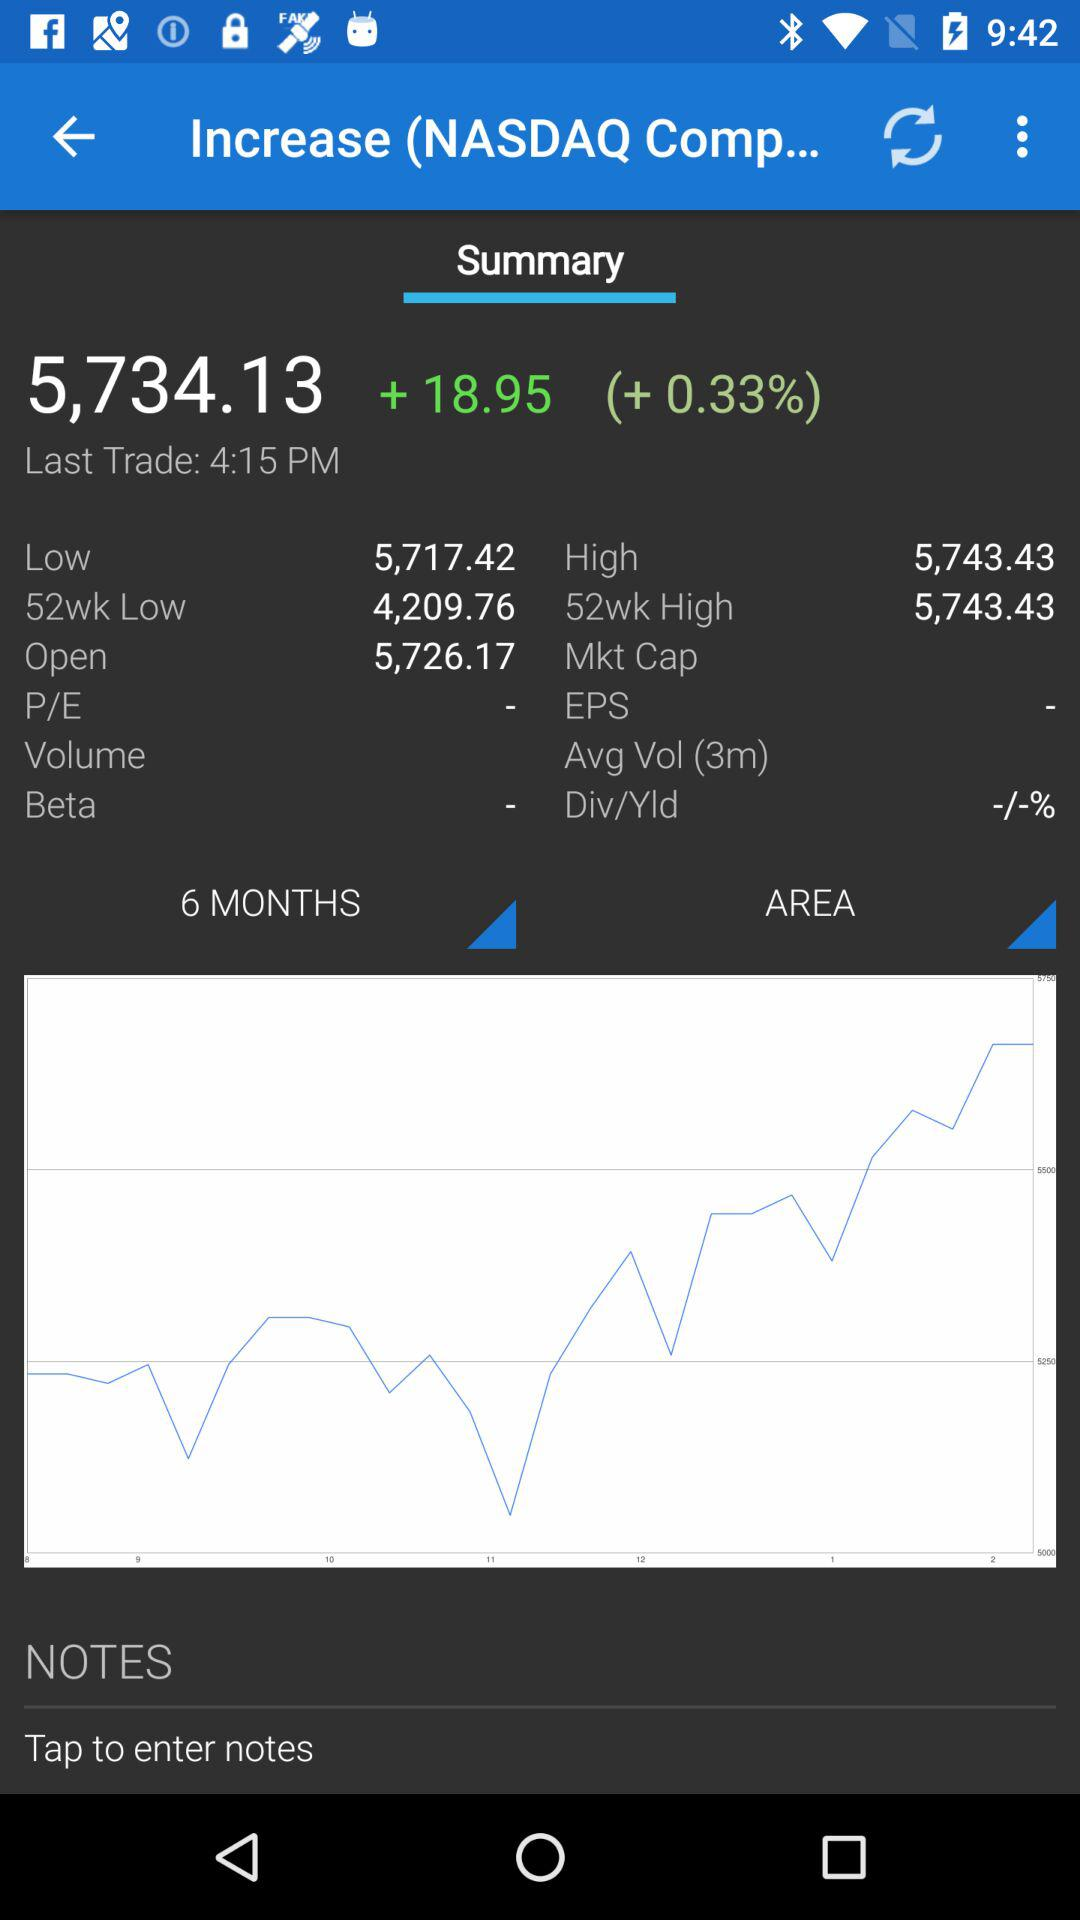What is the percentage change from the open price to the current price?
Answer the question using a single word or phrase. +0.33% 